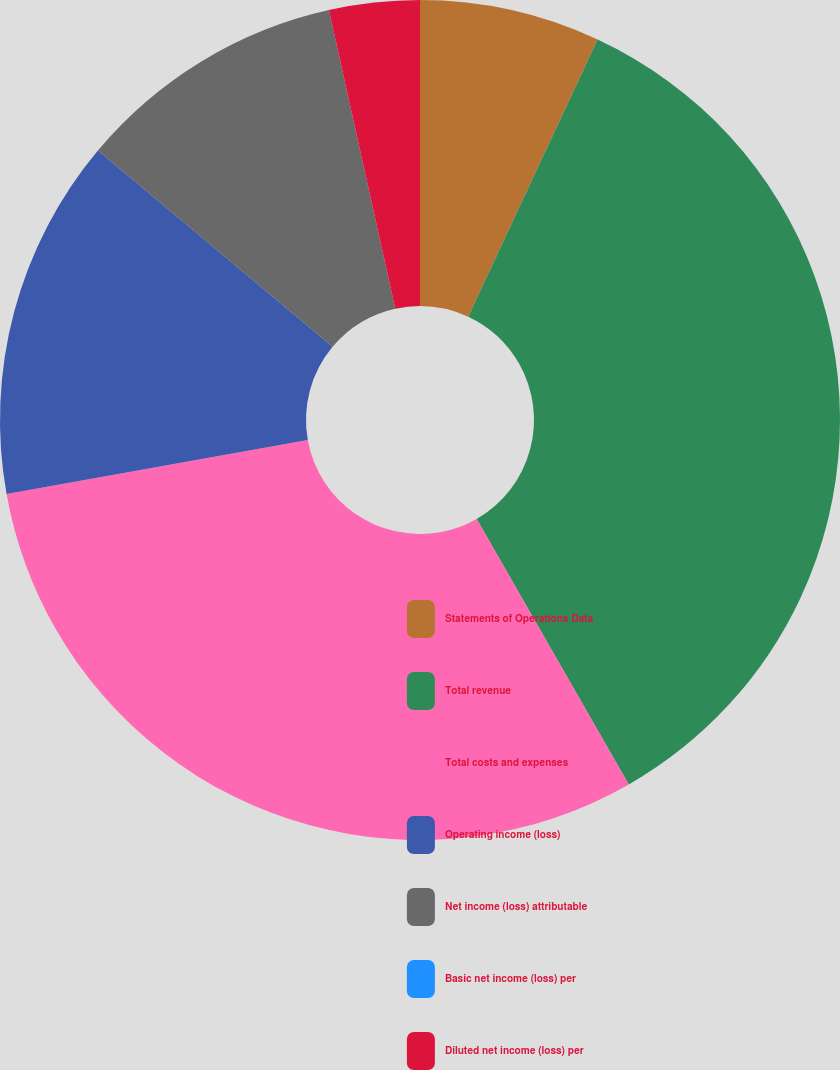Convert chart to OTSL. <chart><loc_0><loc_0><loc_500><loc_500><pie_chart><fcel>Statements of Operations Data<fcel>Total revenue<fcel>Total costs and expenses<fcel>Operating income (loss)<fcel>Net income (loss) attributable<fcel>Basic net income (loss) per<fcel>Diluted net income (loss) per<nl><fcel>6.95%<fcel>34.77%<fcel>30.46%<fcel>13.91%<fcel>10.43%<fcel>0.0%<fcel>3.48%<nl></chart> 